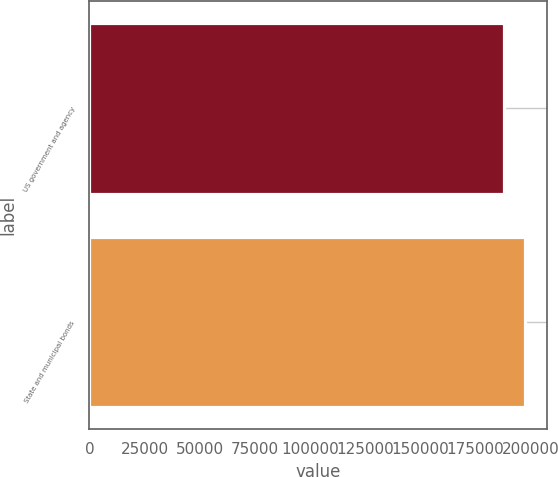Convert chart. <chart><loc_0><loc_0><loc_500><loc_500><bar_chart><fcel>US government and agency<fcel>State and municipal bonds<nl><fcel>187988<fcel>197575<nl></chart> 